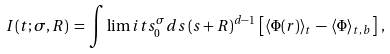<formula> <loc_0><loc_0><loc_500><loc_500>I ( t ; \sigma , R ) \, = \, \int \lim i t s _ { 0 } ^ { \sigma } d s \, ( s + R ) ^ { d - 1 } \, \left [ \langle \Phi ( { r } ) \rangle _ { t } \, - \, \langle \Phi \rangle _ { t , \, b } \right ] \, ,</formula> 